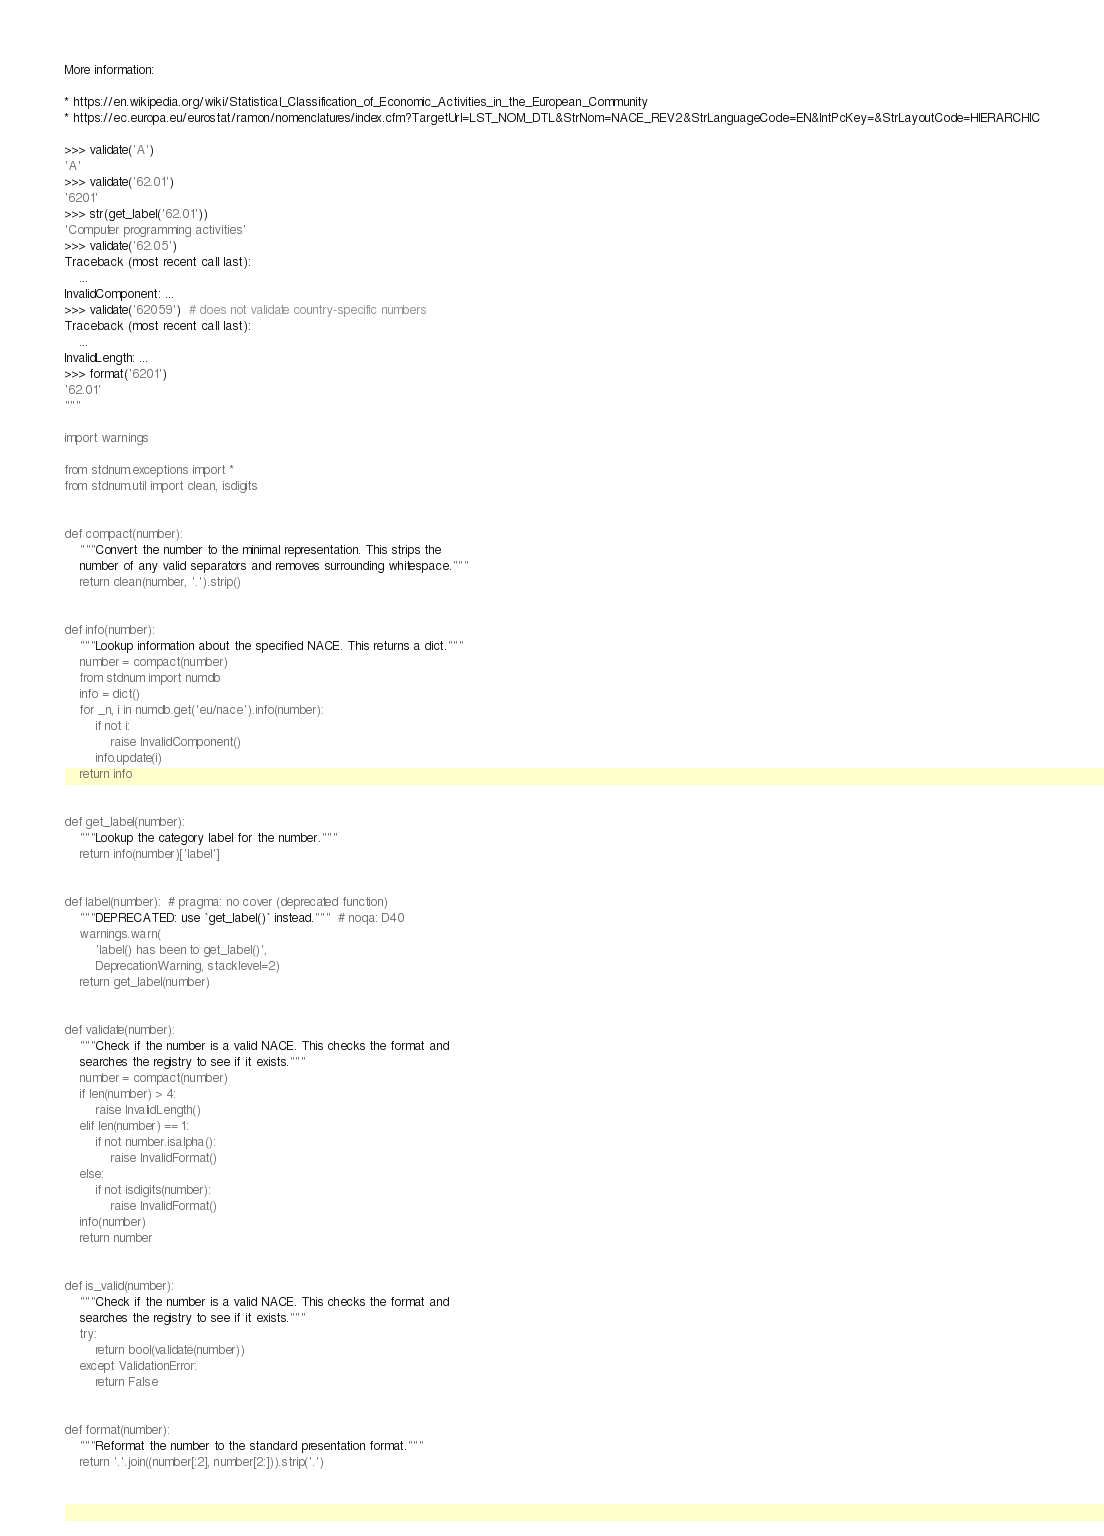Convert code to text. <code><loc_0><loc_0><loc_500><loc_500><_Python_>
More information:

* https://en.wikipedia.org/wiki/Statistical_Classification_of_Economic_Activities_in_the_European_Community
* https://ec.europa.eu/eurostat/ramon/nomenclatures/index.cfm?TargetUrl=LST_NOM_DTL&StrNom=NACE_REV2&StrLanguageCode=EN&IntPcKey=&StrLayoutCode=HIERARCHIC

>>> validate('A')
'A'
>>> validate('62.01')
'6201'
>>> str(get_label('62.01'))
'Computer programming activities'
>>> validate('62.05')
Traceback (most recent call last):
    ...
InvalidComponent: ...
>>> validate('62059')  # does not validate country-specific numbers
Traceback (most recent call last):
    ...
InvalidLength: ...
>>> format('6201')
'62.01'
"""

import warnings

from stdnum.exceptions import *
from stdnum.util import clean, isdigits


def compact(number):
    """Convert the number to the minimal representation. This strips the
    number of any valid separators and removes surrounding whitespace."""
    return clean(number, '.').strip()


def info(number):
    """Lookup information about the specified NACE. This returns a dict."""
    number = compact(number)
    from stdnum import numdb
    info = dict()
    for _n, i in numdb.get('eu/nace').info(number):
        if not i:
            raise InvalidComponent()
        info.update(i)
    return info


def get_label(number):
    """Lookup the category label for the number."""
    return info(number)['label']


def label(number):  # pragma: no cover (deprecated function)
    """DEPRECATED: use `get_label()` instead."""  # noqa: D40
    warnings.warn(
        'label() has been to get_label()',
        DeprecationWarning, stacklevel=2)
    return get_label(number)


def validate(number):
    """Check if the number is a valid NACE. This checks the format and
    searches the registry to see if it exists."""
    number = compact(number)
    if len(number) > 4:
        raise InvalidLength()
    elif len(number) == 1:
        if not number.isalpha():
            raise InvalidFormat()
    else:
        if not isdigits(number):
            raise InvalidFormat()
    info(number)
    return number


def is_valid(number):
    """Check if the number is a valid NACE. This checks the format and
    searches the registry to see if it exists."""
    try:
        return bool(validate(number))
    except ValidationError:
        return False


def format(number):
    """Reformat the number to the standard presentation format."""
    return '.'.join((number[:2], number[2:])).strip('.')
</code> 